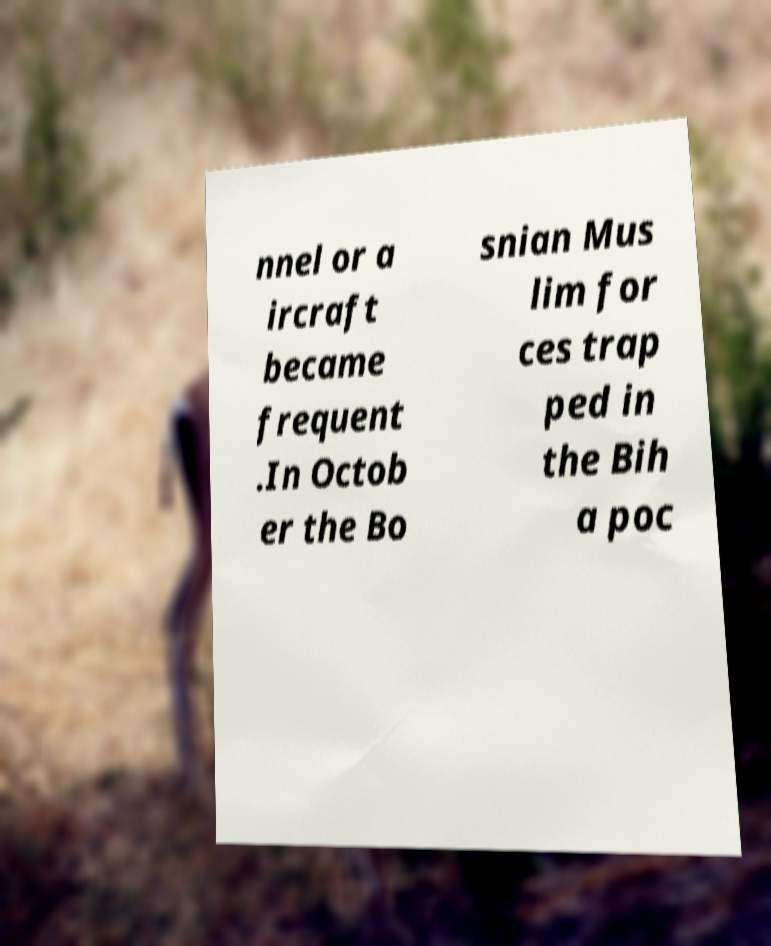What messages or text are displayed in this image? I need them in a readable, typed format. nnel or a ircraft became frequent .In Octob er the Bo snian Mus lim for ces trap ped in the Bih a poc 